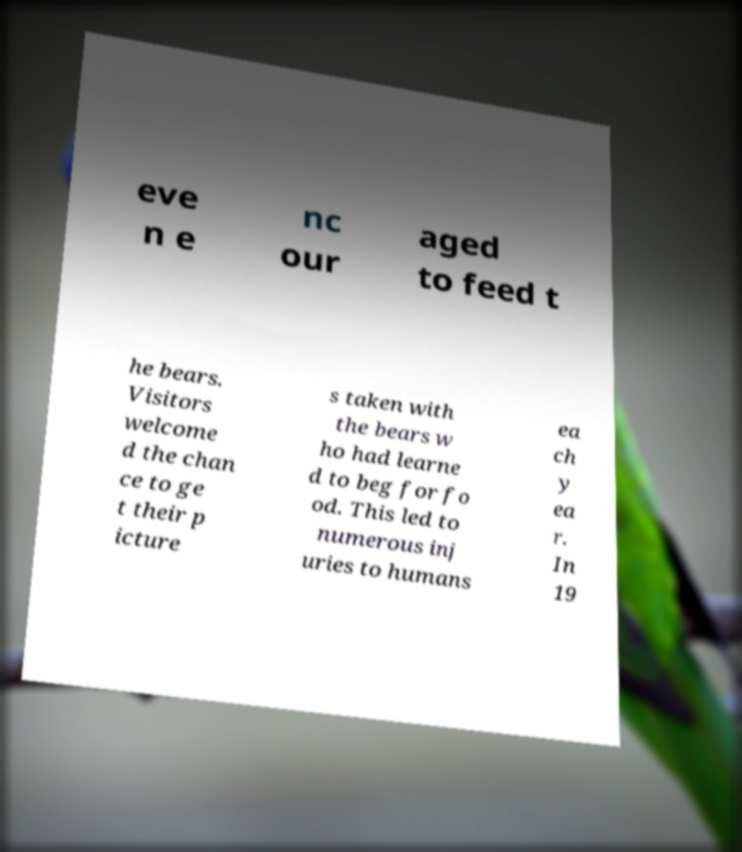What messages or text are displayed in this image? I need them in a readable, typed format. eve n e nc our aged to feed t he bears. Visitors welcome d the chan ce to ge t their p icture s taken with the bears w ho had learne d to beg for fo od. This led to numerous inj uries to humans ea ch y ea r. In 19 